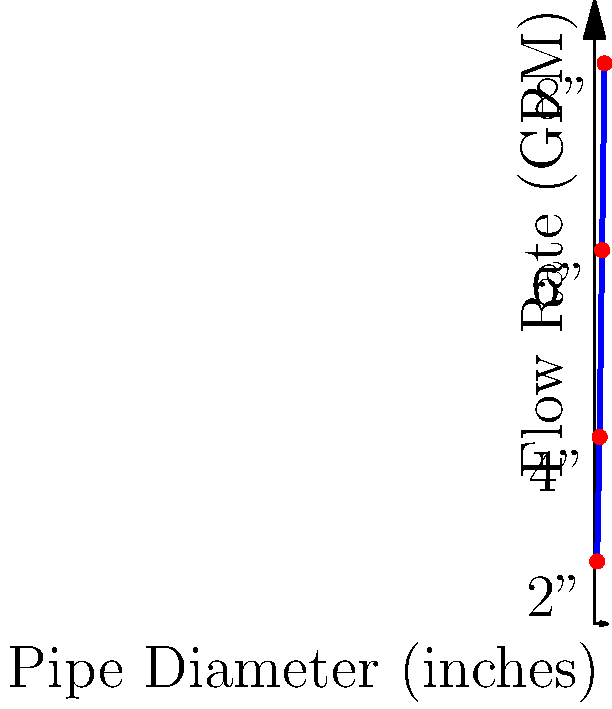Based on the graph showing water flow rates through different pipe diameters, what would be the estimated flow rate for a 5-inch diameter pipe? How does this information impact the decision-making process for selecting pipe sizes in a water distribution system? To answer this question, we need to follow these steps:

1. Analyze the given data:
   - 2" pipe: 50 GPM
   - 4" pipe: 150 GPM
   - 6" pipe: 300 GPM
   - 8" pipe: 450 GPM

2. Observe that the relationship between pipe diameter and flow rate is not linear, but follows a curve.

3. For a 5-inch pipe, we need to estimate the flow rate between the known values for 4" and 6" pipes.

4. Using linear interpolation between 4" and 6" pipes:
   $$(5" - 4") / (6" - 4") = (x - 150 \text{ GPM}) / (300 \text{ GPM} - 150 \text{ GPM})$$
   $$1/2 = (x - 150) / 150$$
   $$x = 150 + (1/2 * 150) = 225 \text{ GPM}$$

5. However, since the relationship is not linear, we should adjust this estimate slightly upward, to approximately 230-235 GPM.

Impact on decision-making:
1. Cost-effectiveness: Larger pipes are more expensive but offer higher flow rates.
2. System capacity: Pipe size directly affects the system's ability to meet peak demand.
3. Pressure management: Smaller pipes may lead to higher pressure losses.
4. Future expansion: Oversizing pipes can accommodate future growth but increases initial costs.
5. Energy efficiency: Larger pipes generally require less pumping energy due to lower friction losses.

This data allows insurance executives to better understand the trade-offs between pipe size, flow capacity, and associated risks, which can inform underwriting decisions for water infrastructure projects.
Answer: Estimated flow rate for 5-inch pipe: ~230-235 GPM 